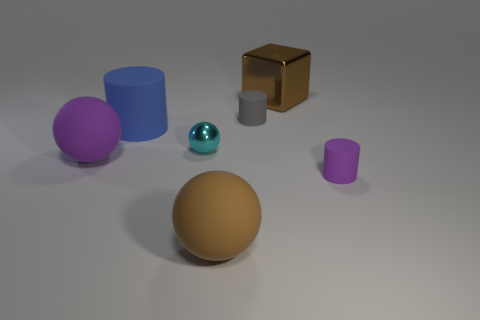Subtract all rubber spheres. How many spheres are left? 1 Subtract all purple cylinders. How many cylinders are left? 2 Add 3 big brown rubber balls. How many objects exist? 10 Subtract all spheres. How many objects are left? 4 Subtract 3 spheres. How many spheres are left? 0 Subtract 0 cyan cylinders. How many objects are left? 7 Subtract all yellow spheres. Subtract all red cylinders. How many spheres are left? 3 Subtract all gray cylinders. How many green blocks are left? 0 Subtract all big rubber cylinders. Subtract all large blue objects. How many objects are left? 5 Add 6 brown blocks. How many brown blocks are left? 7 